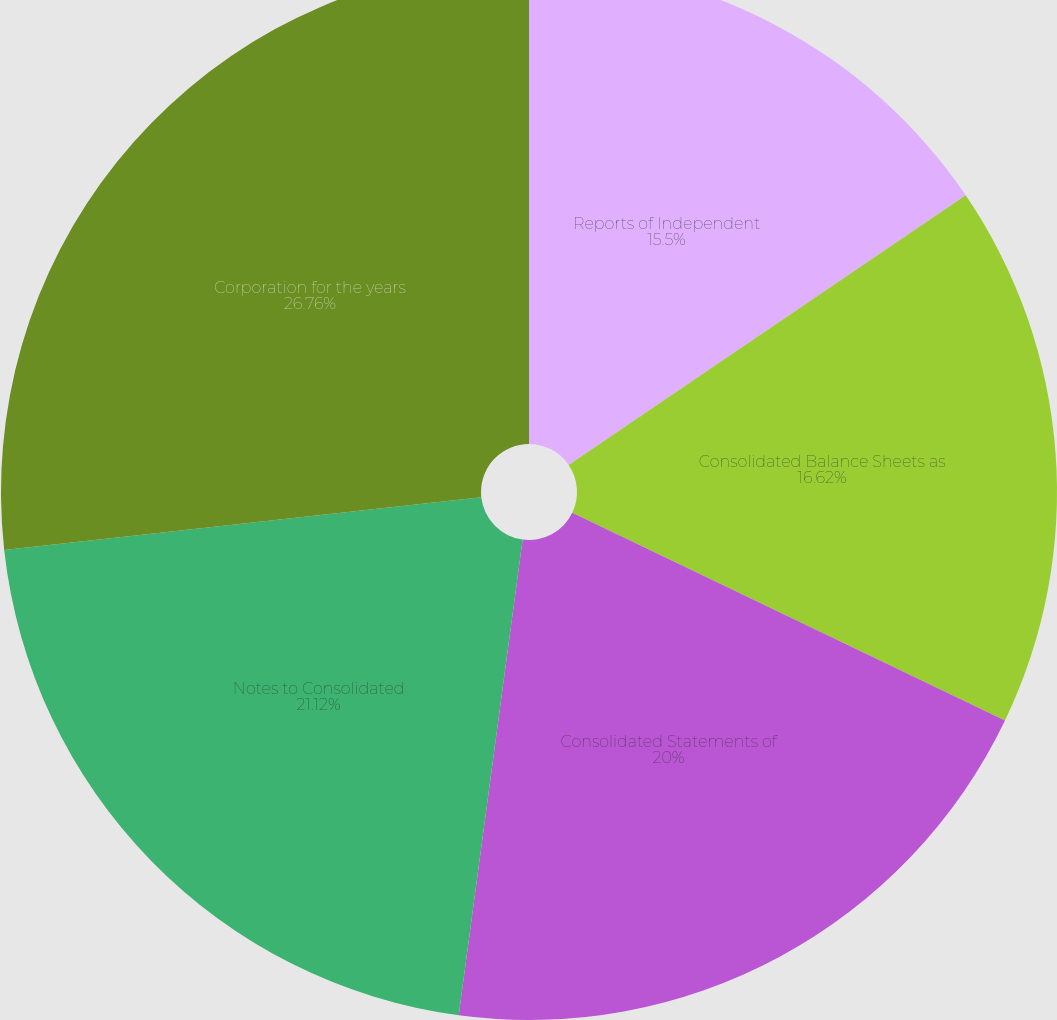Convert chart. <chart><loc_0><loc_0><loc_500><loc_500><pie_chart><fcel>Reports of Independent<fcel>Consolidated Balance Sheets as<fcel>Consolidated Statements of<fcel>Notes to Consolidated<fcel>Corporation for the years<nl><fcel>15.5%<fcel>16.62%<fcel>20.0%<fcel>21.12%<fcel>26.75%<nl></chart> 